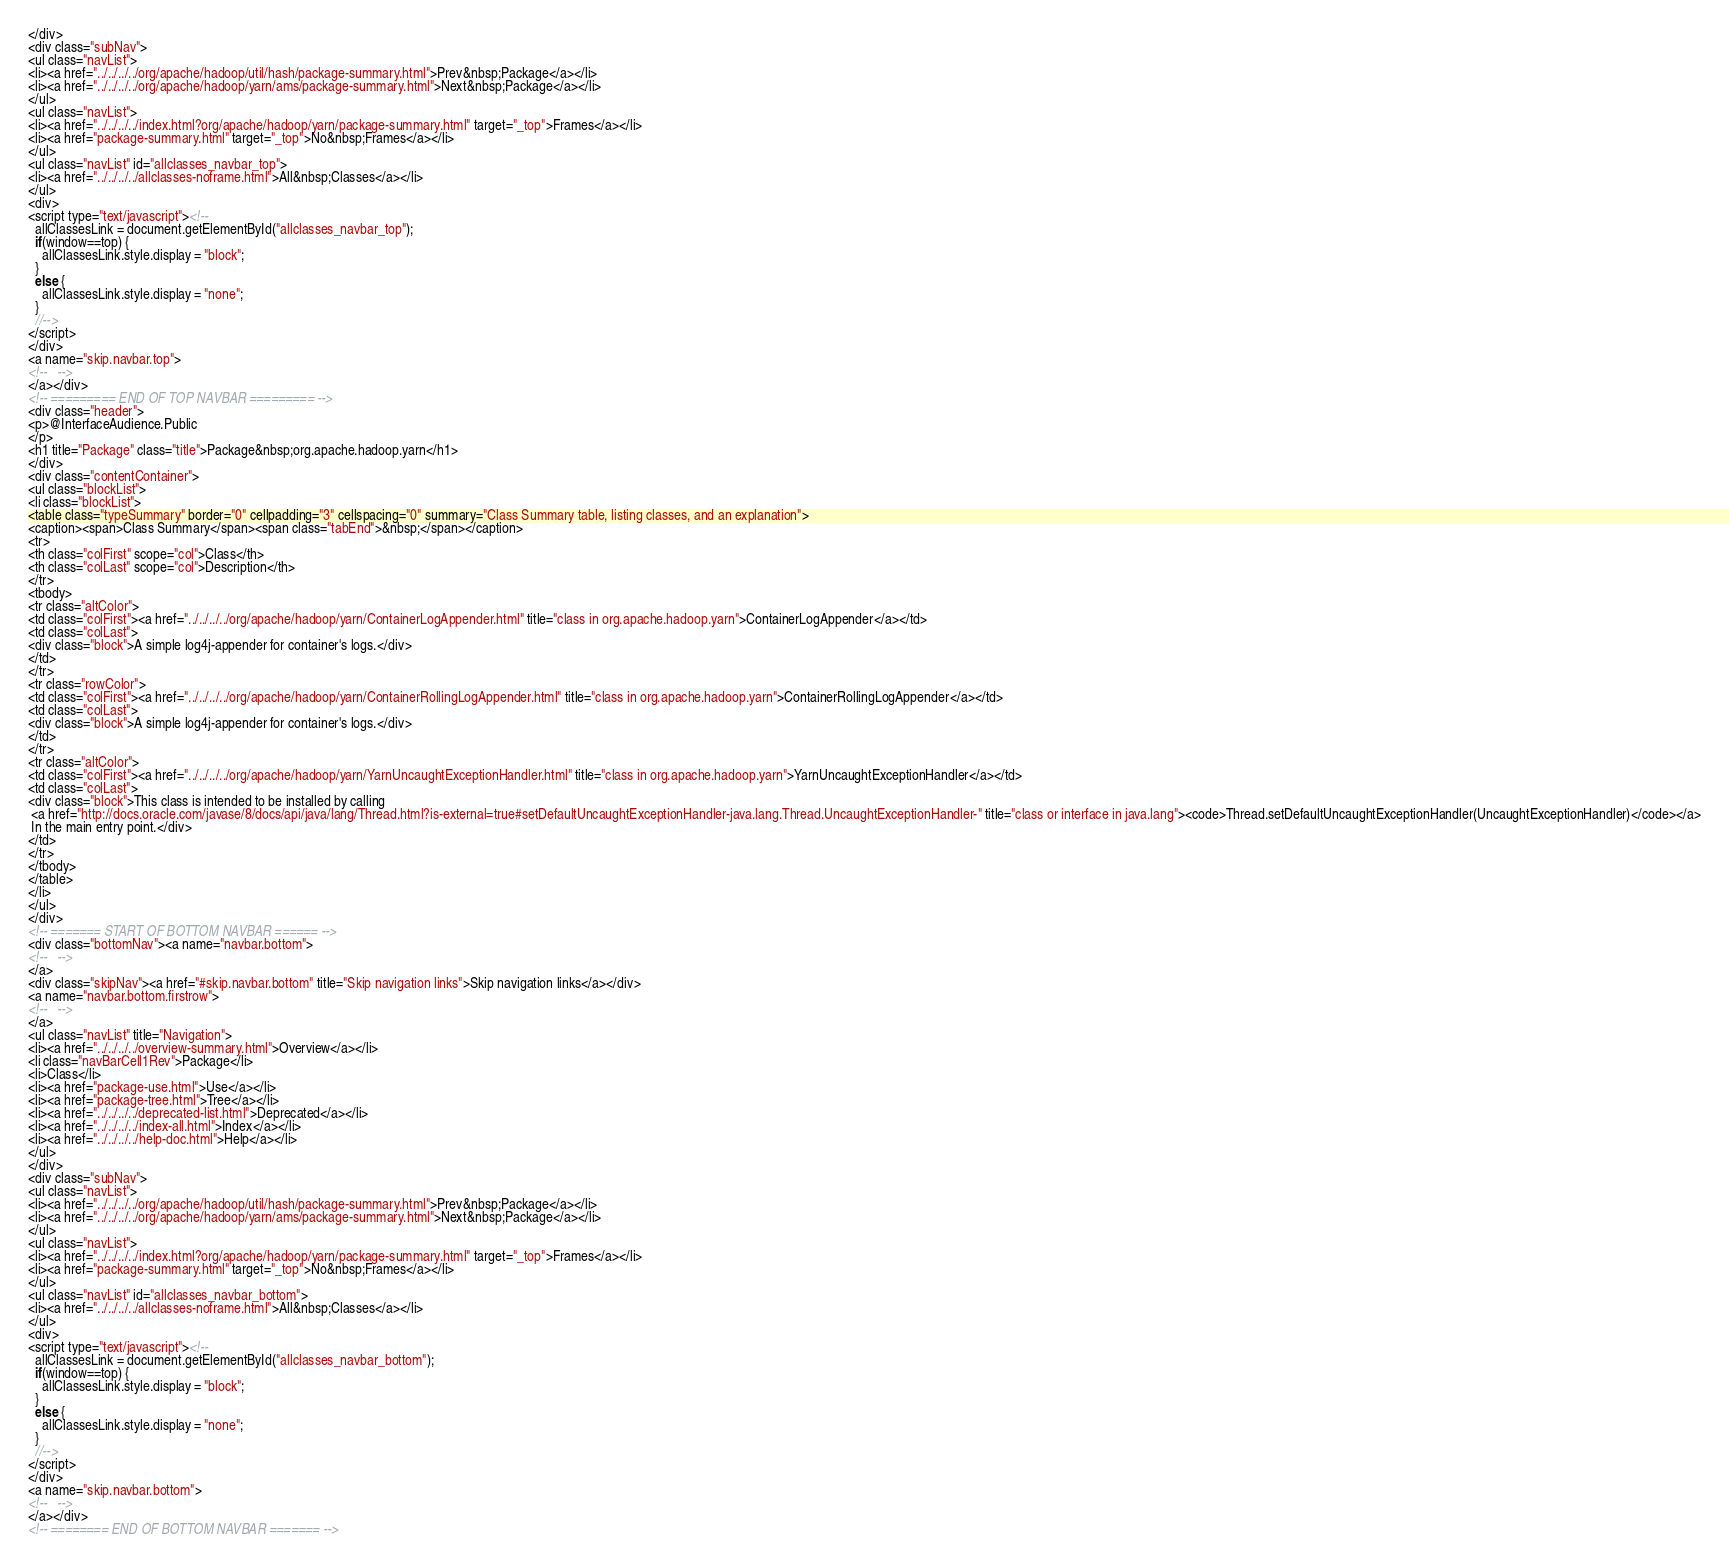Convert code to text. <code><loc_0><loc_0><loc_500><loc_500><_HTML_></div>
<div class="subNav">
<ul class="navList">
<li><a href="../../../../org/apache/hadoop/util/hash/package-summary.html">Prev&nbsp;Package</a></li>
<li><a href="../../../../org/apache/hadoop/yarn/ams/package-summary.html">Next&nbsp;Package</a></li>
</ul>
<ul class="navList">
<li><a href="../../../../index.html?org/apache/hadoop/yarn/package-summary.html" target="_top">Frames</a></li>
<li><a href="package-summary.html" target="_top">No&nbsp;Frames</a></li>
</ul>
<ul class="navList" id="allclasses_navbar_top">
<li><a href="../../../../allclasses-noframe.html">All&nbsp;Classes</a></li>
</ul>
<div>
<script type="text/javascript"><!--
  allClassesLink = document.getElementById("allclasses_navbar_top");
  if(window==top) {
    allClassesLink.style.display = "block";
  }
  else {
    allClassesLink.style.display = "none";
  }
  //-->
</script>
</div>
<a name="skip.navbar.top">
<!--   -->
</a></div>
<!-- ========= END OF TOP NAVBAR ========= -->
<div class="header">
<p>@InterfaceAudience.Public
</p>
<h1 title="Package" class="title">Package&nbsp;org.apache.hadoop.yarn</h1>
</div>
<div class="contentContainer">
<ul class="blockList">
<li class="blockList">
<table class="typeSummary" border="0" cellpadding="3" cellspacing="0" summary="Class Summary table, listing classes, and an explanation">
<caption><span>Class Summary</span><span class="tabEnd">&nbsp;</span></caption>
<tr>
<th class="colFirst" scope="col">Class</th>
<th class="colLast" scope="col">Description</th>
</tr>
<tbody>
<tr class="altColor">
<td class="colFirst"><a href="../../../../org/apache/hadoop/yarn/ContainerLogAppender.html" title="class in org.apache.hadoop.yarn">ContainerLogAppender</a></td>
<td class="colLast">
<div class="block">A simple log4j-appender for container's logs.</div>
</td>
</tr>
<tr class="rowColor">
<td class="colFirst"><a href="../../../../org/apache/hadoop/yarn/ContainerRollingLogAppender.html" title="class in org.apache.hadoop.yarn">ContainerRollingLogAppender</a></td>
<td class="colLast">
<div class="block">A simple log4j-appender for container's logs.</div>
</td>
</tr>
<tr class="altColor">
<td class="colFirst"><a href="../../../../org/apache/hadoop/yarn/YarnUncaughtExceptionHandler.html" title="class in org.apache.hadoop.yarn">YarnUncaughtExceptionHandler</a></td>
<td class="colLast">
<div class="block">This class is intended to be installed by calling 
 <a href="http://docs.oracle.com/javase/8/docs/api/java/lang/Thread.html?is-external=true#setDefaultUncaughtExceptionHandler-java.lang.Thread.UncaughtExceptionHandler-" title="class or interface in java.lang"><code>Thread.setDefaultUncaughtExceptionHandler(UncaughtExceptionHandler)</code></a>
 In the main entry point.</div>
</td>
</tr>
</tbody>
</table>
</li>
</ul>
</div>
<!-- ======= START OF BOTTOM NAVBAR ====== -->
<div class="bottomNav"><a name="navbar.bottom">
<!--   -->
</a>
<div class="skipNav"><a href="#skip.navbar.bottom" title="Skip navigation links">Skip navigation links</a></div>
<a name="navbar.bottom.firstrow">
<!--   -->
</a>
<ul class="navList" title="Navigation">
<li><a href="../../../../overview-summary.html">Overview</a></li>
<li class="navBarCell1Rev">Package</li>
<li>Class</li>
<li><a href="package-use.html">Use</a></li>
<li><a href="package-tree.html">Tree</a></li>
<li><a href="../../../../deprecated-list.html">Deprecated</a></li>
<li><a href="../../../../index-all.html">Index</a></li>
<li><a href="../../../../help-doc.html">Help</a></li>
</ul>
</div>
<div class="subNav">
<ul class="navList">
<li><a href="../../../../org/apache/hadoop/util/hash/package-summary.html">Prev&nbsp;Package</a></li>
<li><a href="../../../../org/apache/hadoop/yarn/ams/package-summary.html">Next&nbsp;Package</a></li>
</ul>
<ul class="navList">
<li><a href="../../../../index.html?org/apache/hadoop/yarn/package-summary.html" target="_top">Frames</a></li>
<li><a href="package-summary.html" target="_top">No&nbsp;Frames</a></li>
</ul>
<ul class="navList" id="allclasses_navbar_bottom">
<li><a href="../../../../allclasses-noframe.html">All&nbsp;Classes</a></li>
</ul>
<div>
<script type="text/javascript"><!--
  allClassesLink = document.getElementById("allclasses_navbar_bottom");
  if(window==top) {
    allClassesLink.style.display = "block";
  }
  else {
    allClassesLink.style.display = "none";
  }
  //-->
</script>
</div>
<a name="skip.navbar.bottom">
<!--   -->
</a></div>
<!-- ======== END OF BOTTOM NAVBAR ======= --></code> 